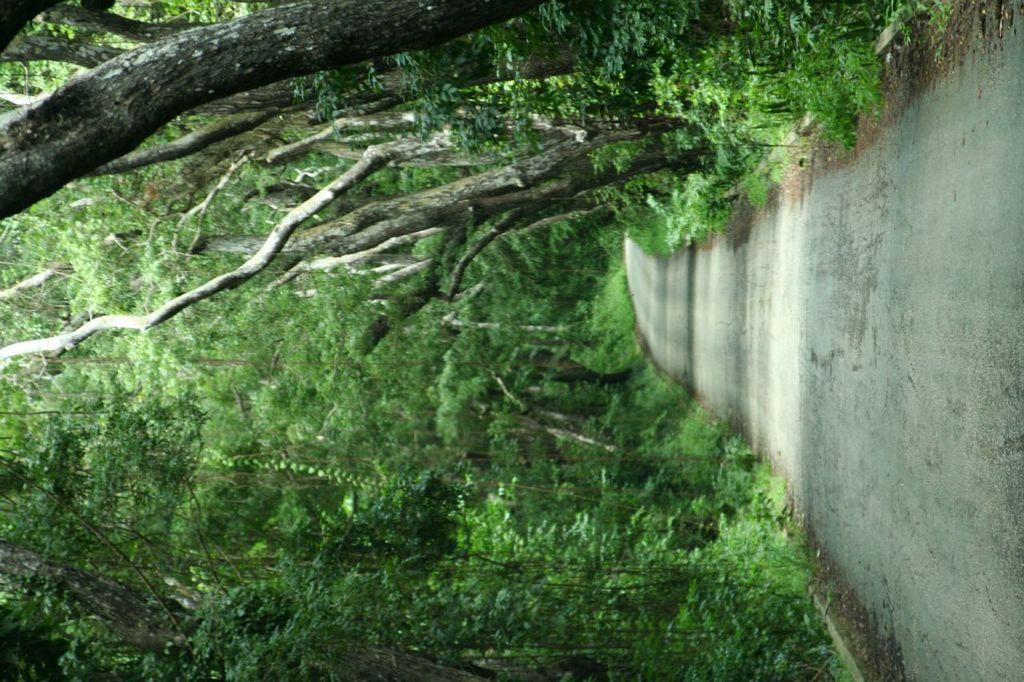What is the main feature of the image? There is a road in the image. What can be seen on both sides of the road? There are trees on either side of the road. How many mailboxes are present along the road in the image? There is no mention of mailboxes in the image, so we cannot determine their presence or quantity. 